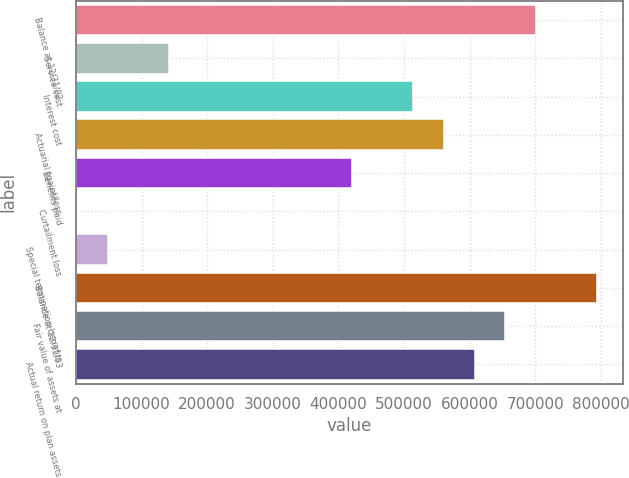Convert chart. <chart><loc_0><loc_0><loc_500><loc_500><bar_chart><fcel>Balance at 12/31/02<fcel>Service cost<fcel>Interest cost<fcel>Actuarial (gain)/loss<fcel>Benefits paid<fcel>Curtailment loss<fcel>Special termination benefits<fcel>Balance at 12/31/03<fcel>Fair value of assets at<fcel>Actual return on plan assets<nl><fcel>700619<fcel>141630<fcel>514289<fcel>560872<fcel>421125<fcel>1883<fcel>48465.4<fcel>793784<fcel>654037<fcel>607454<nl></chart> 